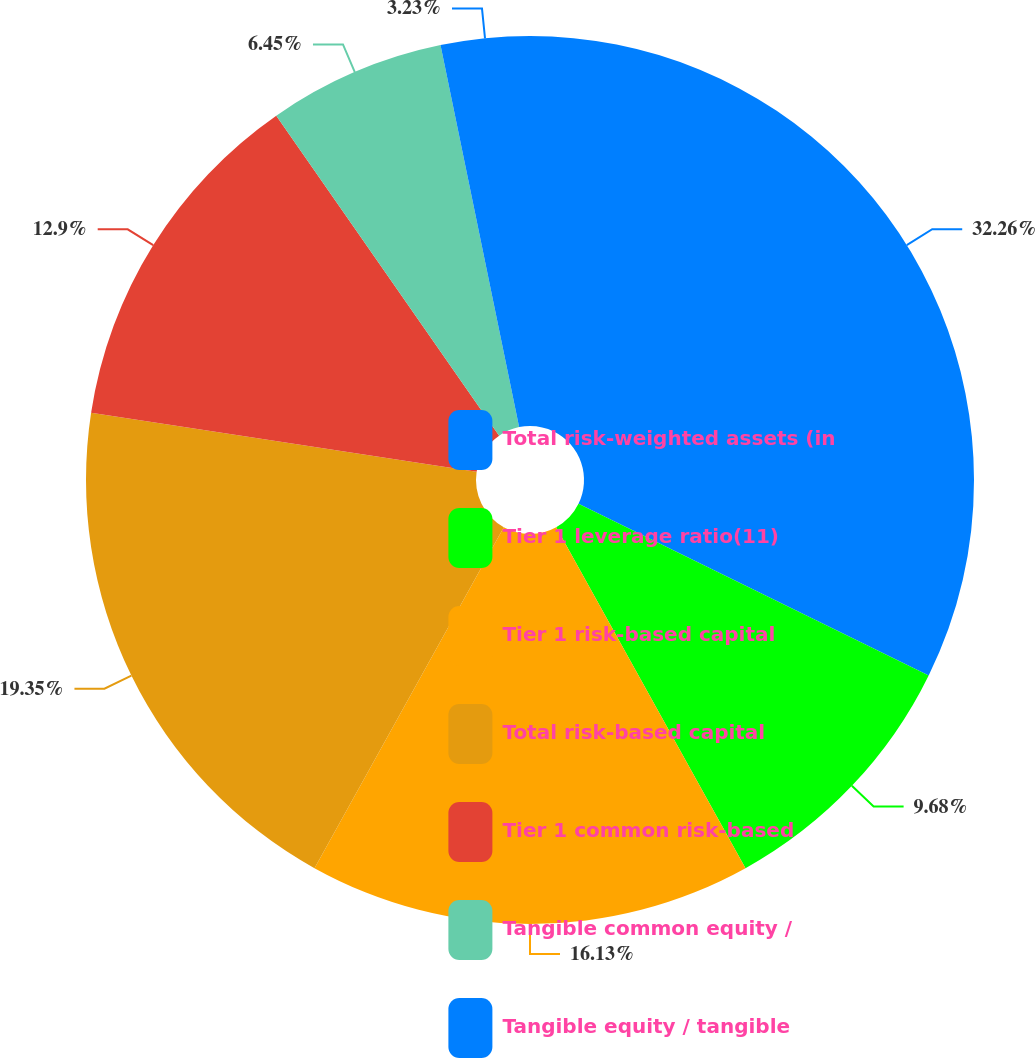Convert chart to OTSL. <chart><loc_0><loc_0><loc_500><loc_500><pie_chart><fcel>Total risk-weighted assets (in<fcel>Tier 1 leverage ratio(11)<fcel>Tier 1 risk-based capital<fcel>Total risk-based capital<fcel>Tier 1 common risk-based<fcel>Tangible common equity /<fcel>Tangible equity / tangible<nl><fcel>32.25%<fcel>9.68%<fcel>16.13%<fcel>19.35%<fcel>12.9%<fcel>6.45%<fcel>3.23%<nl></chart> 